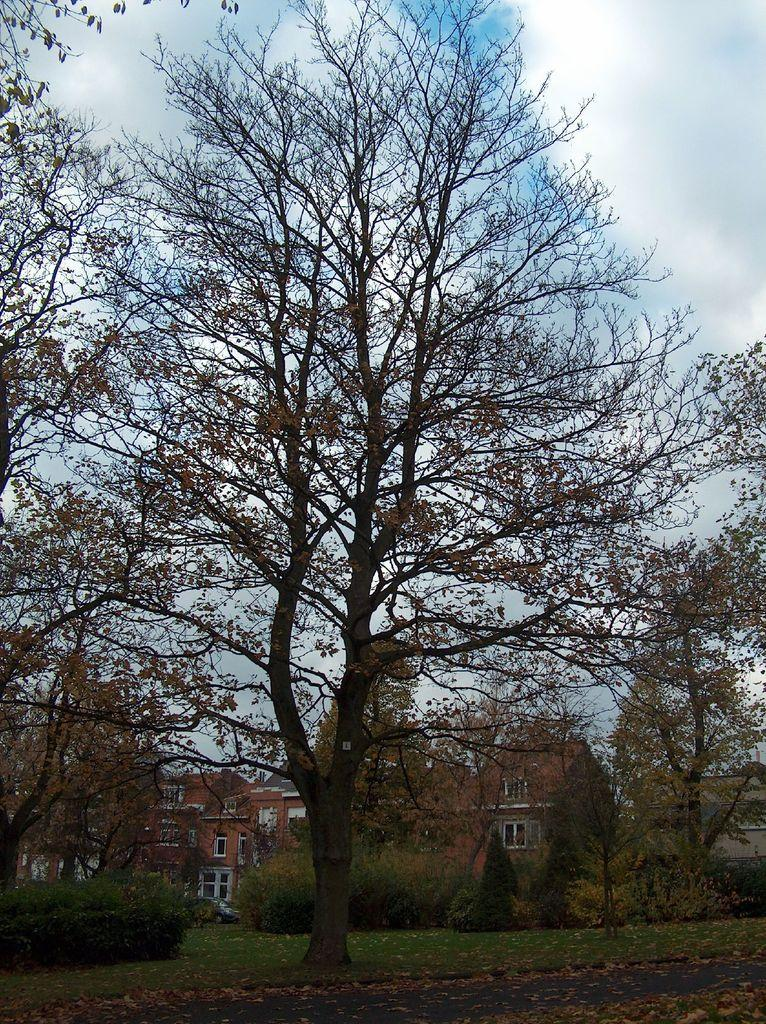What type of structures can be seen in the image? There are houses in the image. What type of vegetation is present in the image? There are trees, bushes, plants, and grass on the ground in the image. What can be found on the ground among the vegetation? There are dried leaves on the ground in the image. What is the condition of the sky in the image? The sky is cloudy in the image. What type of party is being held in the image? There is no party present in the image; it features houses, vegetation, and a cloudy sky. What scientific theory can be observed in the image? There is no scientific theory depicted in the image; it is a scene of houses, vegetation, and a cloudy sky. 